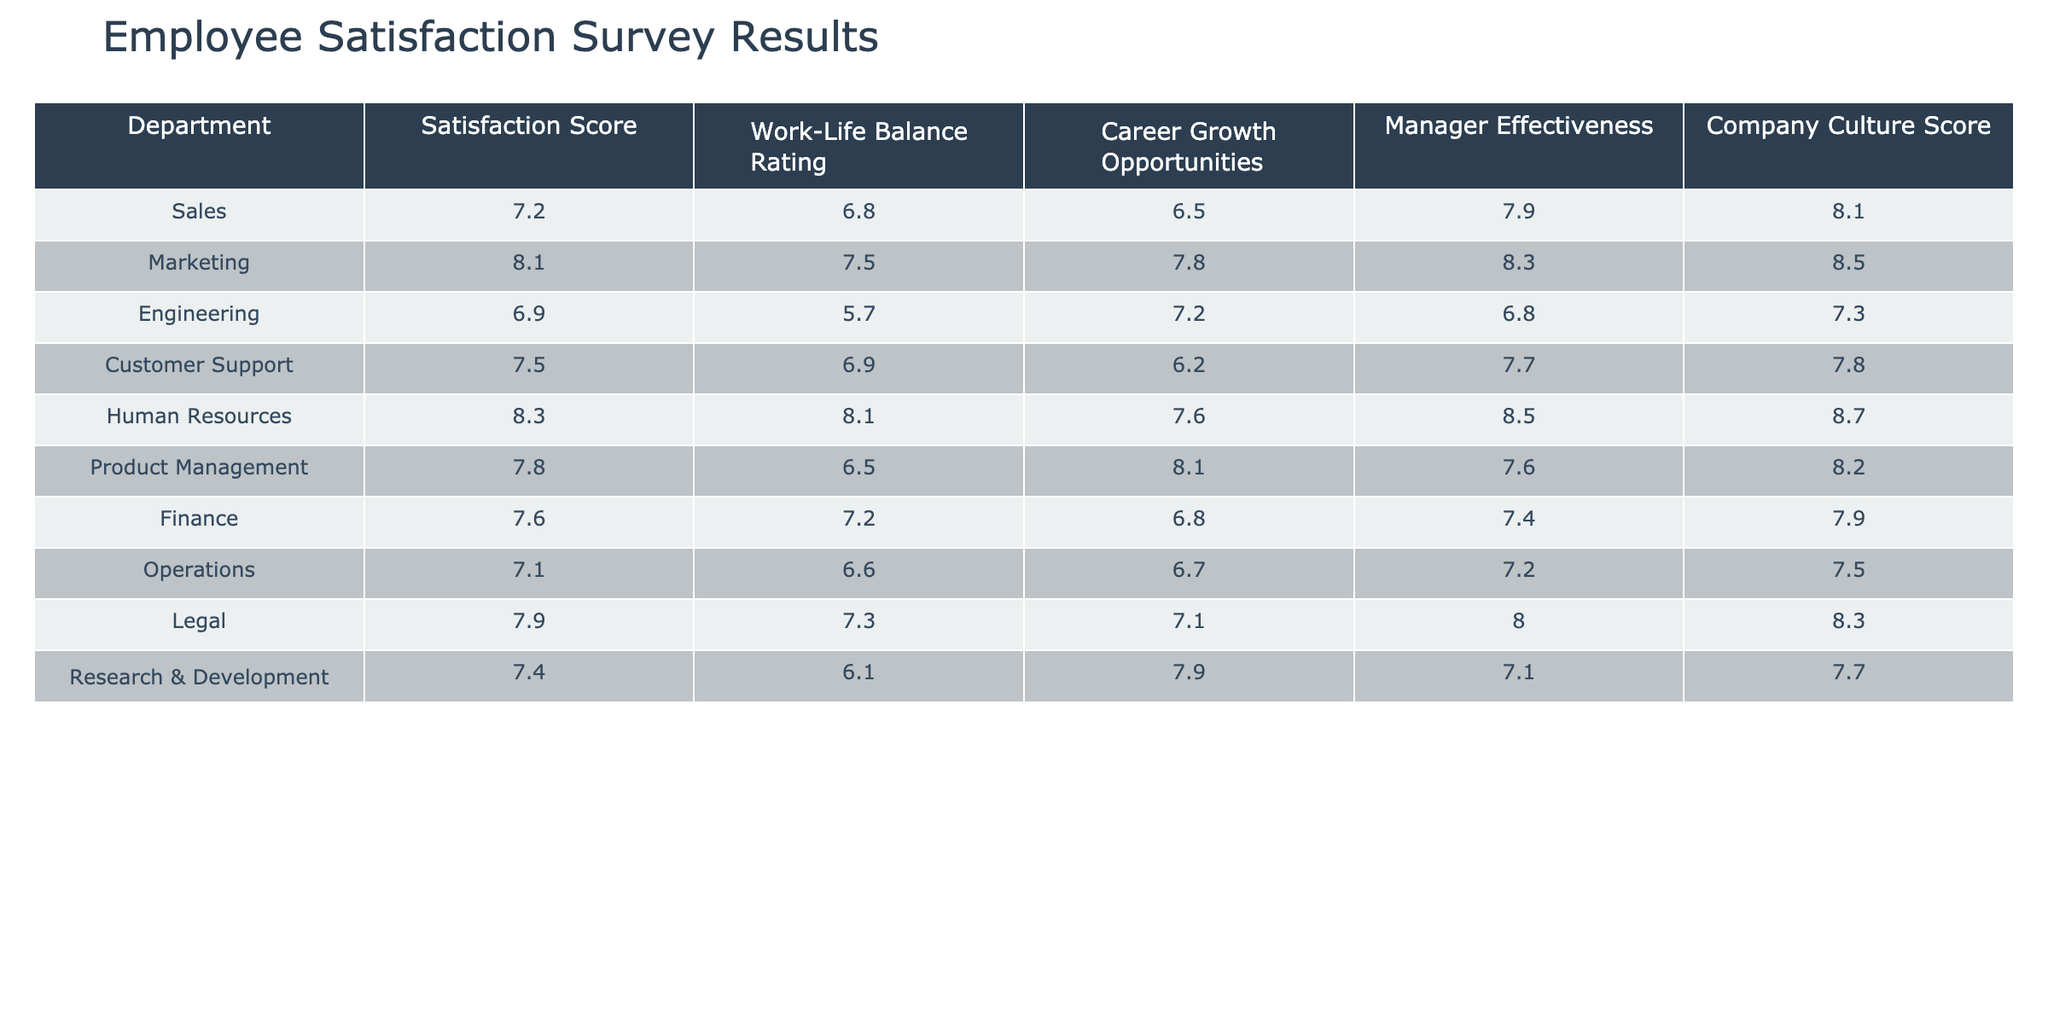What's the satisfaction score for the Marketing department? The table shows that the satisfaction score for the Marketing department is listed as 8.1.
Answer: 8.1 Which department has the highest company culture score? By looking through the table, Human Resources has the highest company culture score of 8.7.
Answer: Human Resources What is the average work-life balance rating across all departments? To find the average, add all the work-life balance ratings: (6.8 + 7.5 + 5.7 + 6.9 + 8.1 + 6.5 + 7.2 + 6.6 + 7.3 + 6.1) = 69.7. Now divide by the number of departments, which is 10. So the average is 69.7/10 = 6.97.
Answer: 6.97 Is the satisfaction score for Customer Support greater than 7.5? The satisfaction score for Customer Support is 7.5, which is not greater than 7.5. Therefore, the statement is false.
Answer: No Which department has the lowest career growth opportunities rating? By checking the ratings, we see that Customer Support has the lowest rating at 6.2.
Answer: Customer Support What is the difference in manager effectiveness between Sales and Engineering? The manager effectiveness for Sales is 7.9, and for Engineering, it is 6.8. The difference is calculated as 7.9 - 6.8 = 1.1.
Answer: 1.1 Which department's satisfaction score is closest to the average satisfaction score of all departments? The average satisfaction score is (7.2 + 8.1 + 6.9 + 7.5 + 8.3 + 7.8 + 7.6 + 7.1 + 7.9 + 7.4) / 10 = 7.54. The department closest to this is Finance with a score of 7.6.
Answer: Finance What is the company culture score for the department with the lowest satisfaction score? The Engineering department has the lowest satisfaction score of 6.9, and its company culture score is 7.3.
Answer: 7.3 Are there any departments with a work-life balance rating above 8? From the table, Human Resources has a work-life balance rating of 8.1, which is above 8. Therefore, the answer is yes.
Answer: Yes Which two departments have the most similar scores for career growth opportunities? The career growth ratings for Product Management (8.1) and Human Resources (7.6) are closest together. Other departments have more significant differences.
Answer: Product Management and Human Resources 